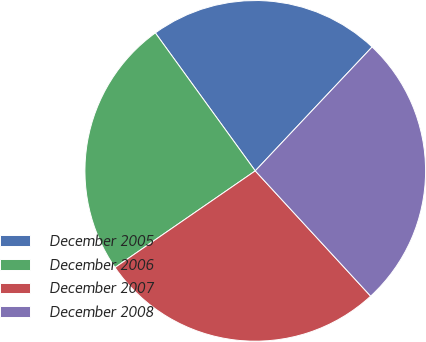<chart> <loc_0><loc_0><loc_500><loc_500><pie_chart><fcel>December 2005<fcel>December 2006<fcel>December 2007<fcel>December 2008<nl><fcel>22.01%<fcel>24.63%<fcel>27.24%<fcel>26.12%<nl></chart> 